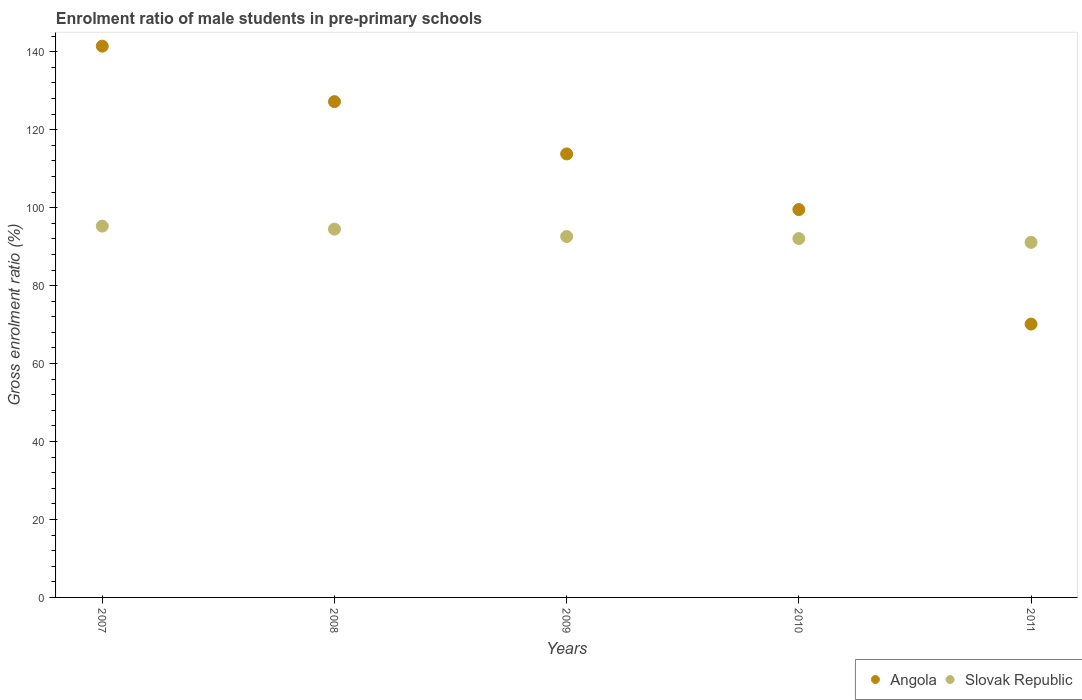How many different coloured dotlines are there?
Ensure brevity in your answer.  2. What is the enrolment ratio of male students in pre-primary schools in Angola in 2007?
Ensure brevity in your answer.  141.44. Across all years, what is the maximum enrolment ratio of male students in pre-primary schools in Angola?
Your answer should be compact. 141.44. Across all years, what is the minimum enrolment ratio of male students in pre-primary schools in Slovak Republic?
Your answer should be compact. 91.1. In which year was the enrolment ratio of male students in pre-primary schools in Slovak Republic maximum?
Ensure brevity in your answer.  2007. What is the total enrolment ratio of male students in pre-primary schools in Angola in the graph?
Keep it short and to the point. 552.06. What is the difference between the enrolment ratio of male students in pre-primary schools in Slovak Republic in 2009 and that in 2010?
Make the answer very short. 0.52. What is the difference between the enrolment ratio of male students in pre-primary schools in Slovak Republic in 2010 and the enrolment ratio of male students in pre-primary schools in Angola in 2009?
Your response must be concise. -21.72. What is the average enrolment ratio of male students in pre-primary schools in Angola per year?
Your answer should be very brief. 110.41. In the year 2011, what is the difference between the enrolment ratio of male students in pre-primary schools in Slovak Republic and enrolment ratio of male students in pre-primary schools in Angola?
Your answer should be very brief. 20.97. What is the ratio of the enrolment ratio of male students in pre-primary schools in Slovak Republic in 2010 to that in 2011?
Your answer should be compact. 1.01. What is the difference between the highest and the second highest enrolment ratio of male students in pre-primary schools in Slovak Republic?
Offer a very short reply. 0.77. What is the difference between the highest and the lowest enrolment ratio of male students in pre-primary schools in Angola?
Give a very brief answer. 71.31. Is the enrolment ratio of male students in pre-primary schools in Angola strictly greater than the enrolment ratio of male students in pre-primary schools in Slovak Republic over the years?
Give a very brief answer. No. Is the enrolment ratio of male students in pre-primary schools in Slovak Republic strictly less than the enrolment ratio of male students in pre-primary schools in Angola over the years?
Your answer should be very brief. No. How many dotlines are there?
Provide a short and direct response. 2. How many years are there in the graph?
Your answer should be compact. 5. Where does the legend appear in the graph?
Offer a very short reply. Bottom right. What is the title of the graph?
Provide a short and direct response. Enrolment ratio of male students in pre-primary schools. Does "South Africa" appear as one of the legend labels in the graph?
Provide a succinct answer. No. What is the Gross enrolment ratio (%) of Angola in 2007?
Provide a succinct answer. 141.44. What is the Gross enrolment ratio (%) in Slovak Republic in 2007?
Offer a terse response. 95.26. What is the Gross enrolment ratio (%) in Angola in 2008?
Make the answer very short. 127.2. What is the Gross enrolment ratio (%) of Slovak Republic in 2008?
Offer a very short reply. 94.49. What is the Gross enrolment ratio (%) in Angola in 2009?
Ensure brevity in your answer.  113.79. What is the Gross enrolment ratio (%) of Slovak Republic in 2009?
Your answer should be very brief. 92.6. What is the Gross enrolment ratio (%) of Angola in 2010?
Keep it short and to the point. 99.51. What is the Gross enrolment ratio (%) of Slovak Republic in 2010?
Offer a terse response. 92.07. What is the Gross enrolment ratio (%) of Angola in 2011?
Your response must be concise. 70.12. What is the Gross enrolment ratio (%) of Slovak Republic in 2011?
Keep it short and to the point. 91.1. Across all years, what is the maximum Gross enrolment ratio (%) of Angola?
Your response must be concise. 141.44. Across all years, what is the maximum Gross enrolment ratio (%) in Slovak Republic?
Offer a terse response. 95.26. Across all years, what is the minimum Gross enrolment ratio (%) in Angola?
Your response must be concise. 70.12. Across all years, what is the minimum Gross enrolment ratio (%) of Slovak Republic?
Keep it short and to the point. 91.1. What is the total Gross enrolment ratio (%) of Angola in the graph?
Your response must be concise. 552.06. What is the total Gross enrolment ratio (%) in Slovak Republic in the graph?
Provide a succinct answer. 465.52. What is the difference between the Gross enrolment ratio (%) of Angola in 2007 and that in 2008?
Keep it short and to the point. 14.24. What is the difference between the Gross enrolment ratio (%) in Slovak Republic in 2007 and that in 2008?
Ensure brevity in your answer.  0.77. What is the difference between the Gross enrolment ratio (%) in Angola in 2007 and that in 2009?
Your response must be concise. 27.65. What is the difference between the Gross enrolment ratio (%) of Slovak Republic in 2007 and that in 2009?
Your answer should be very brief. 2.67. What is the difference between the Gross enrolment ratio (%) in Angola in 2007 and that in 2010?
Offer a terse response. 41.92. What is the difference between the Gross enrolment ratio (%) in Slovak Republic in 2007 and that in 2010?
Your answer should be compact. 3.19. What is the difference between the Gross enrolment ratio (%) of Angola in 2007 and that in 2011?
Offer a very short reply. 71.31. What is the difference between the Gross enrolment ratio (%) in Slovak Republic in 2007 and that in 2011?
Give a very brief answer. 4.16. What is the difference between the Gross enrolment ratio (%) in Angola in 2008 and that in 2009?
Give a very brief answer. 13.41. What is the difference between the Gross enrolment ratio (%) in Slovak Republic in 2008 and that in 2009?
Provide a short and direct response. 1.89. What is the difference between the Gross enrolment ratio (%) in Angola in 2008 and that in 2010?
Offer a terse response. 27.68. What is the difference between the Gross enrolment ratio (%) of Slovak Republic in 2008 and that in 2010?
Keep it short and to the point. 2.42. What is the difference between the Gross enrolment ratio (%) of Angola in 2008 and that in 2011?
Provide a succinct answer. 57.07. What is the difference between the Gross enrolment ratio (%) of Slovak Republic in 2008 and that in 2011?
Provide a short and direct response. 3.39. What is the difference between the Gross enrolment ratio (%) of Angola in 2009 and that in 2010?
Keep it short and to the point. 14.27. What is the difference between the Gross enrolment ratio (%) of Slovak Republic in 2009 and that in 2010?
Offer a very short reply. 0.52. What is the difference between the Gross enrolment ratio (%) in Angola in 2009 and that in 2011?
Offer a terse response. 43.66. What is the difference between the Gross enrolment ratio (%) in Slovak Republic in 2009 and that in 2011?
Provide a short and direct response. 1.5. What is the difference between the Gross enrolment ratio (%) of Angola in 2010 and that in 2011?
Offer a very short reply. 29.39. What is the difference between the Gross enrolment ratio (%) of Slovak Republic in 2010 and that in 2011?
Offer a terse response. 0.97. What is the difference between the Gross enrolment ratio (%) in Angola in 2007 and the Gross enrolment ratio (%) in Slovak Republic in 2008?
Ensure brevity in your answer.  46.95. What is the difference between the Gross enrolment ratio (%) of Angola in 2007 and the Gross enrolment ratio (%) of Slovak Republic in 2009?
Your response must be concise. 48.84. What is the difference between the Gross enrolment ratio (%) in Angola in 2007 and the Gross enrolment ratio (%) in Slovak Republic in 2010?
Provide a succinct answer. 49.37. What is the difference between the Gross enrolment ratio (%) in Angola in 2007 and the Gross enrolment ratio (%) in Slovak Republic in 2011?
Your answer should be compact. 50.34. What is the difference between the Gross enrolment ratio (%) of Angola in 2008 and the Gross enrolment ratio (%) of Slovak Republic in 2009?
Provide a short and direct response. 34.6. What is the difference between the Gross enrolment ratio (%) of Angola in 2008 and the Gross enrolment ratio (%) of Slovak Republic in 2010?
Your answer should be compact. 35.13. What is the difference between the Gross enrolment ratio (%) in Angola in 2008 and the Gross enrolment ratio (%) in Slovak Republic in 2011?
Ensure brevity in your answer.  36.1. What is the difference between the Gross enrolment ratio (%) in Angola in 2009 and the Gross enrolment ratio (%) in Slovak Republic in 2010?
Offer a terse response. 21.72. What is the difference between the Gross enrolment ratio (%) of Angola in 2009 and the Gross enrolment ratio (%) of Slovak Republic in 2011?
Provide a succinct answer. 22.69. What is the difference between the Gross enrolment ratio (%) of Angola in 2010 and the Gross enrolment ratio (%) of Slovak Republic in 2011?
Ensure brevity in your answer.  8.42. What is the average Gross enrolment ratio (%) of Angola per year?
Your answer should be very brief. 110.41. What is the average Gross enrolment ratio (%) of Slovak Republic per year?
Keep it short and to the point. 93.1. In the year 2007, what is the difference between the Gross enrolment ratio (%) of Angola and Gross enrolment ratio (%) of Slovak Republic?
Ensure brevity in your answer.  46.17. In the year 2008, what is the difference between the Gross enrolment ratio (%) in Angola and Gross enrolment ratio (%) in Slovak Republic?
Give a very brief answer. 32.71. In the year 2009, what is the difference between the Gross enrolment ratio (%) of Angola and Gross enrolment ratio (%) of Slovak Republic?
Offer a terse response. 21.19. In the year 2010, what is the difference between the Gross enrolment ratio (%) of Angola and Gross enrolment ratio (%) of Slovak Republic?
Ensure brevity in your answer.  7.44. In the year 2011, what is the difference between the Gross enrolment ratio (%) of Angola and Gross enrolment ratio (%) of Slovak Republic?
Your answer should be very brief. -20.97. What is the ratio of the Gross enrolment ratio (%) in Angola in 2007 to that in 2008?
Your response must be concise. 1.11. What is the ratio of the Gross enrolment ratio (%) in Slovak Republic in 2007 to that in 2008?
Your response must be concise. 1.01. What is the ratio of the Gross enrolment ratio (%) of Angola in 2007 to that in 2009?
Offer a very short reply. 1.24. What is the ratio of the Gross enrolment ratio (%) of Slovak Republic in 2007 to that in 2009?
Your answer should be very brief. 1.03. What is the ratio of the Gross enrolment ratio (%) of Angola in 2007 to that in 2010?
Your answer should be very brief. 1.42. What is the ratio of the Gross enrolment ratio (%) in Slovak Republic in 2007 to that in 2010?
Your answer should be compact. 1.03. What is the ratio of the Gross enrolment ratio (%) of Angola in 2007 to that in 2011?
Make the answer very short. 2.02. What is the ratio of the Gross enrolment ratio (%) in Slovak Republic in 2007 to that in 2011?
Your answer should be very brief. 1.05. What is the ratio of the Gross enrolment ratio (%) in Angola in 2008 to that in 2009?
Your answer should be compact. 1.12. What is the ratio of the Gross enrolment ratio (%) of Slovak Republic in 2008 to that in 2009?
Provide a succinct answer. 1.02. What is the ratio of the Gross enrolment ratio (%) of Angola in 2008 to that in 2010?
Ensure brevity in your answer.  1.28. What is the ratio of the Gross enrolment ratio (%) in Slovak Republic in 2008 to that in 2010?
Keep it short and to the point. 1.03. What is the ratio of the Gross enrolment ratio (%) of Angola in 2008 to that in 2011?
Your response must be concise. 1.81. What is the ratio of the Gross enrolment ratio (%) in Slovak Republic in 2008 to that in 2011?
Give a very brief answer. 1.04. What is the ratio of the Gross enrolment ratio (%) in Angola in 2009 to that in 2010?
Provide a short and direct response. 1.14. What is the ratio of the Gross enrolment ratio (%) in Angola in 2009 to that in 2011?
Ensure brevity in your answer.  1.62. What is the ratio of the Gross enrolment ratio (%) in Slovak Republic in 2009 to that in 2011?
Your response must be concise. 1.02. What is the ratio of the Gross enrolment ratio (%) of Angola in 2010 to that in 2011?
Keep it short and to the point. 1.42. What is the ratio of the Gross enrolment ratio (%) in Slovak Republic in 2010 to that in 2011?
Keep it short and to the point. 1.01. What is the difference between the highest and the second highest Gross enrolment ratio (%) in Angola?
Provide a succinct answer. 14.24. What is the difference between the highest and the second highest Gross enrolment ratio (%) of Slovak Republic?
Your response must be concise. 0.77. What is the difference between the highest and the lowest Gross enrolment ratio (%) of Angola?
Provide a short and direct response. 71.31. What is the difference between the highest and the lowest Gross enrolment ratio (%) in Slovak Republic?
Your response must be concise. 4.16. 